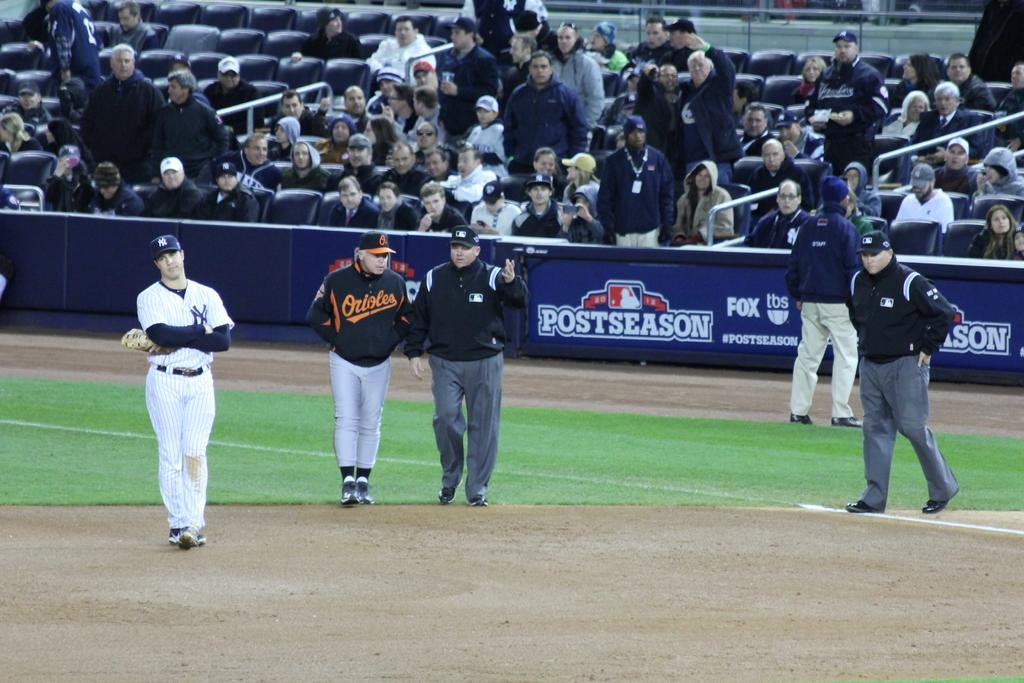<image>
Describe the image concisely. The Orioles and the Yankees were playing in this game. 